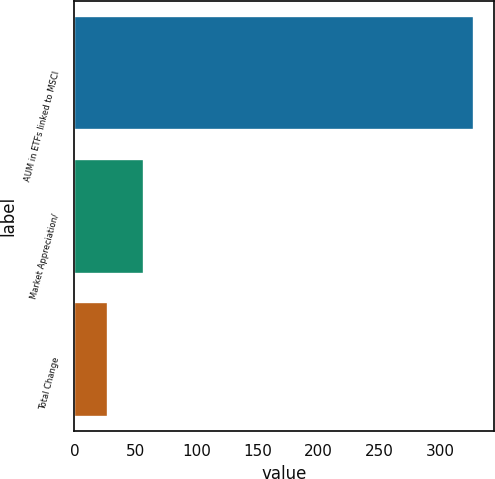Convert chart. <chart><loc_0><loc_0><loc_500><loc_500><bar_chart><fcel>AUM in ETFs linked to MSCI<fcel>Market Appreciation/<fcel>Total Change<nl><fcel>327.4<fcel>57.31<fcel>27.3<nl></chart> 